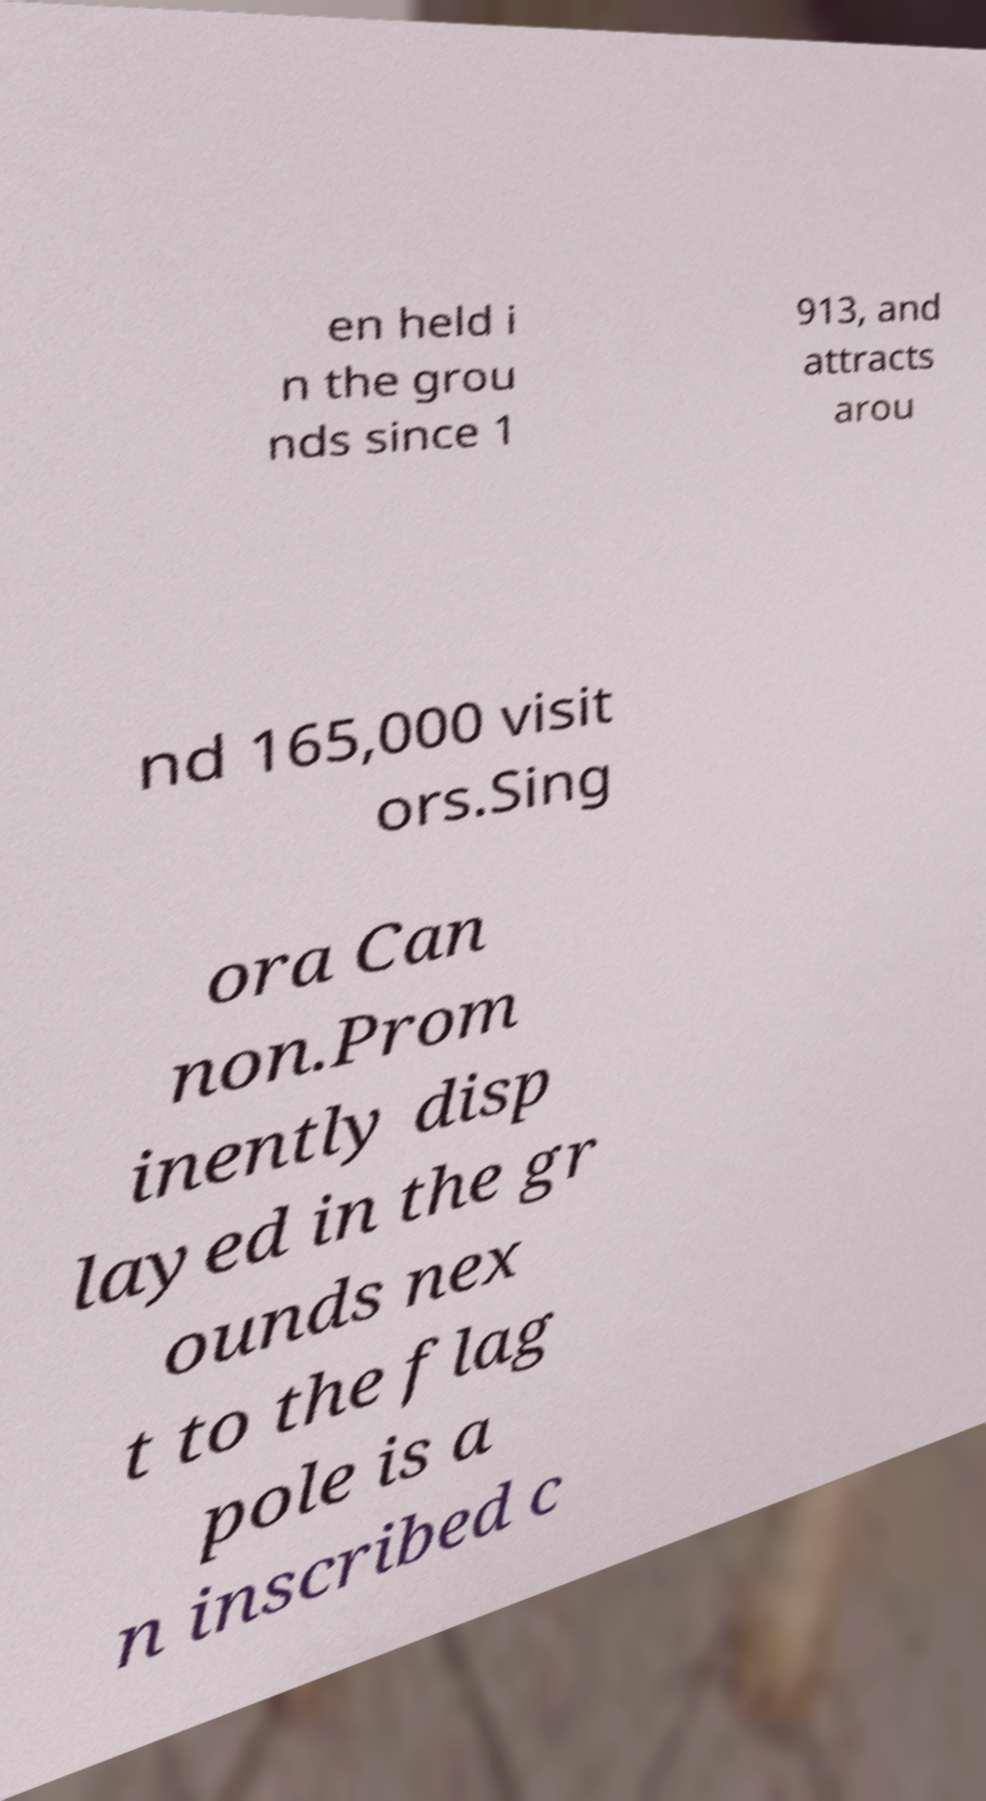Can you read and provide the text displayed in the image?This photo seems to have some interesting text. Can you extract and type it out for me? en held i n the grou nds since 1 913, and attracts arou nd 165,000 visit ors.Sing ora Can non.Prom inently disp layed in the gr ounds nex t to the flag pole is a n inscribed c 